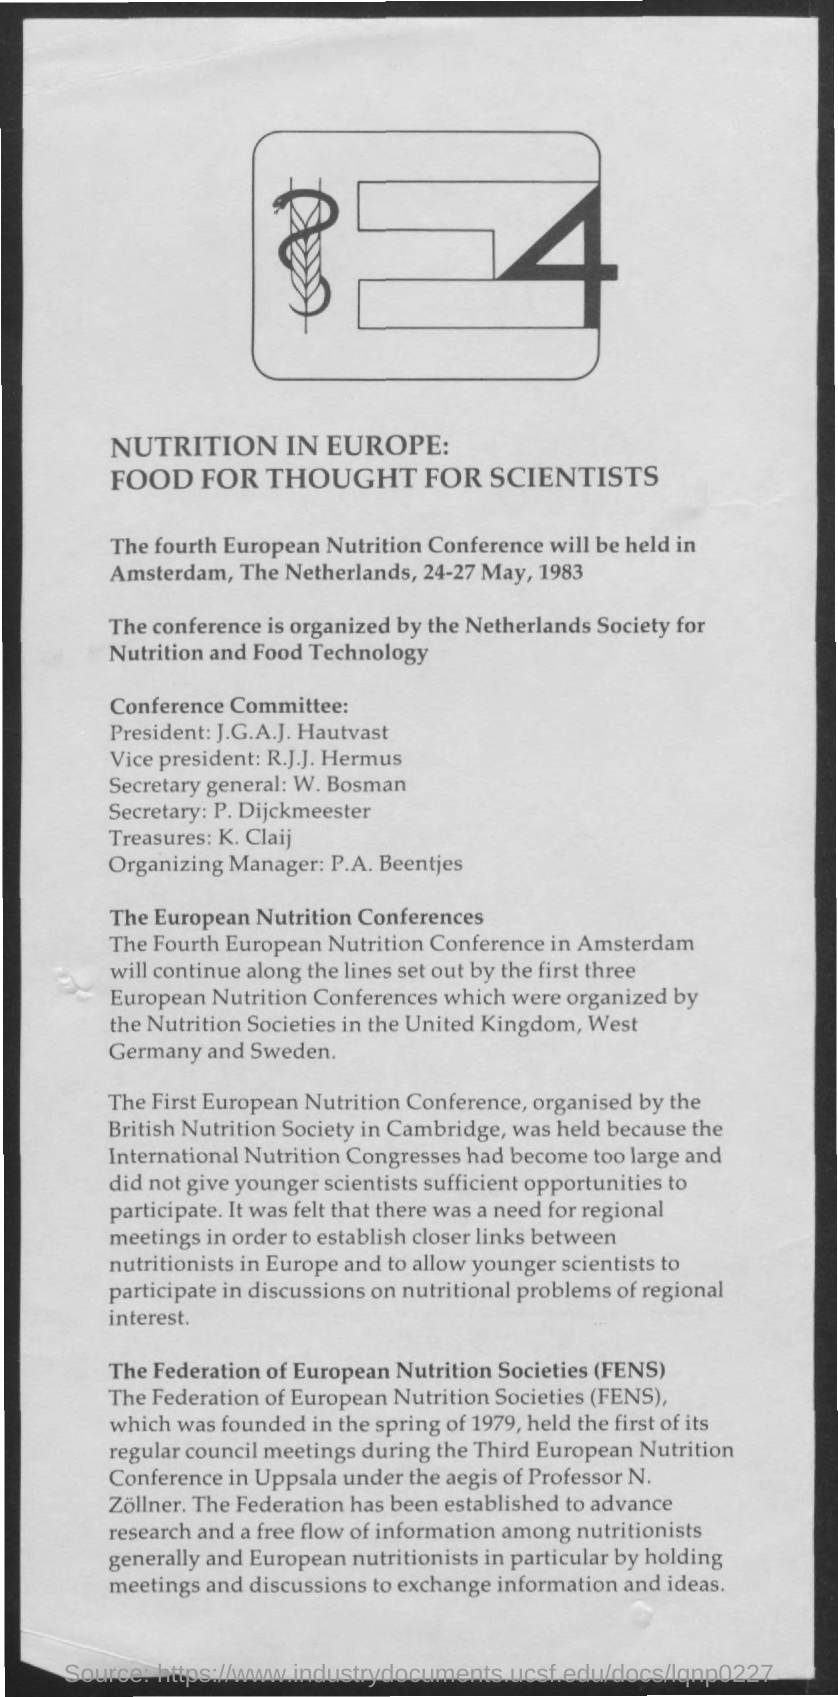Give some essential details in this illustration. The fourth European Nutrition Conference will be held from May 24th to May 27th, 1983. The Secretary General of the Conference Committee is William Bosman. The Federation of European Nutrition Societies (FENS) is a well-known organization that represents the interests of various nutrition societies throughout Europe. The Vice President of the Conference Committee is R.J.J. Hermus. The President of the Conference Committee is John G. A. J. Hautvast. 